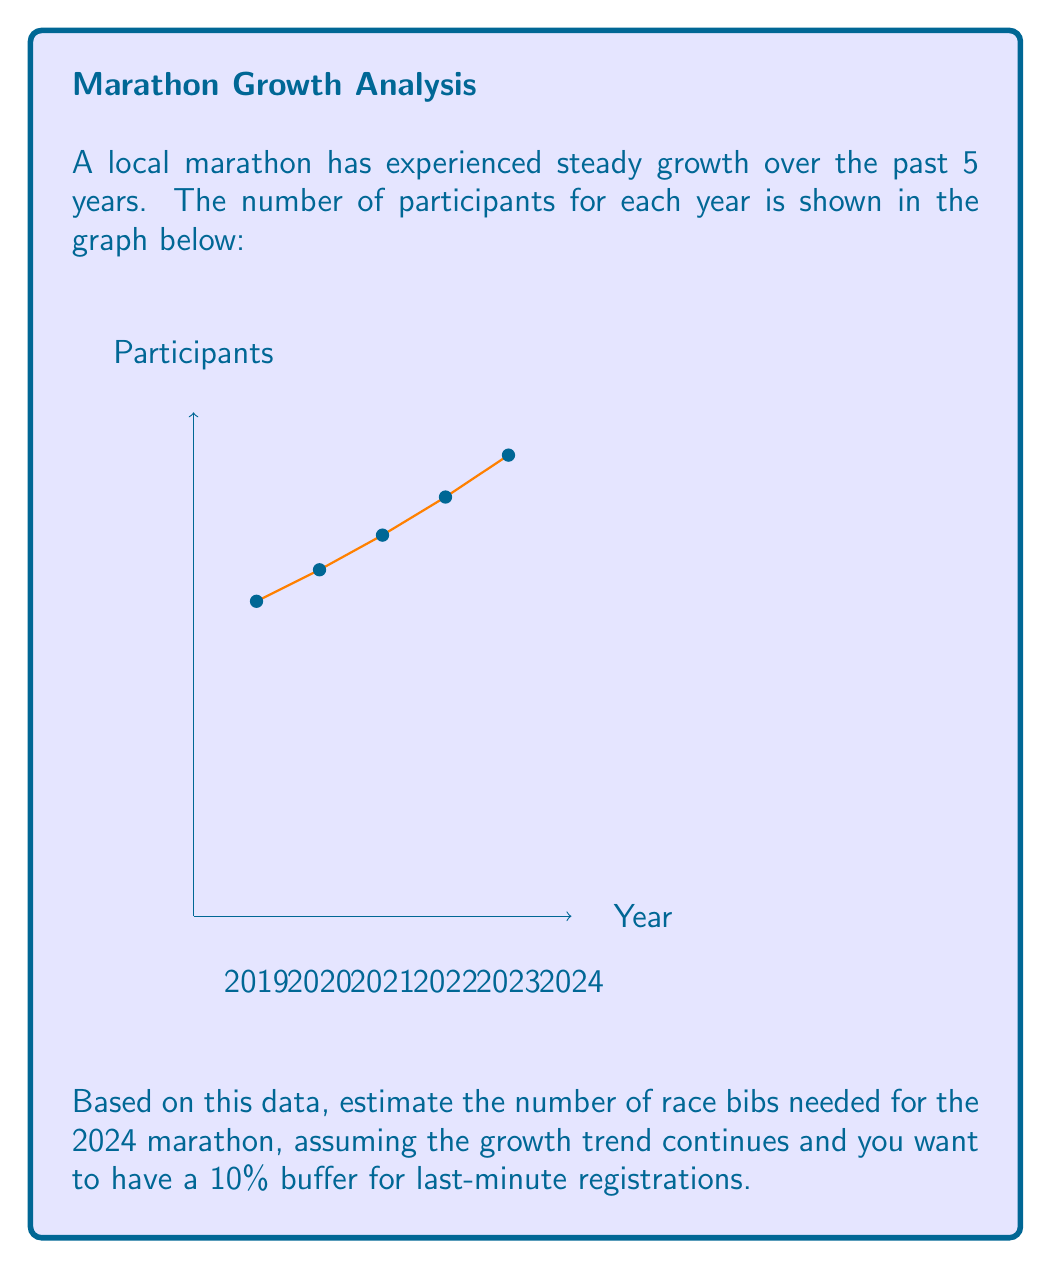Can you solve this math problem? To solve this problem, we'll follow these steps:

1) First, let's calculate the year-over-year growth rate:

   2019 to 2020: $\frac{5500 - 5000}{5000} = 10\%$
   2020 to 2021: $\frac{6050 - 5500}{5500} = 10\%$
   2021 to 2022: $\frac{6655 - 6050}{6050} = 10\%$
   2022 to 2023: $\frac{7320 - 6655}{6655} = 10\%$

   We can see a consistent 10% growth each year.

2) To estimate the number of participants for 2024, we apply this 10% growth to the 2023 number:

   $7320 \times 1.10 = 8052$ participants

3) Now, we need to add a 10% buffer for last-minute registrations:

   $8052 \times 1.10 = 8857.2$

4) Since we can't have a fractional number of race bibs, we round up to the nearest whole number:

   $8857.2 \rightarrow 8858$ race bibs

Therefore, the event coordinator should order 8858 race bibs for the 2024 marathon.
Answer: 8858 race bibs 